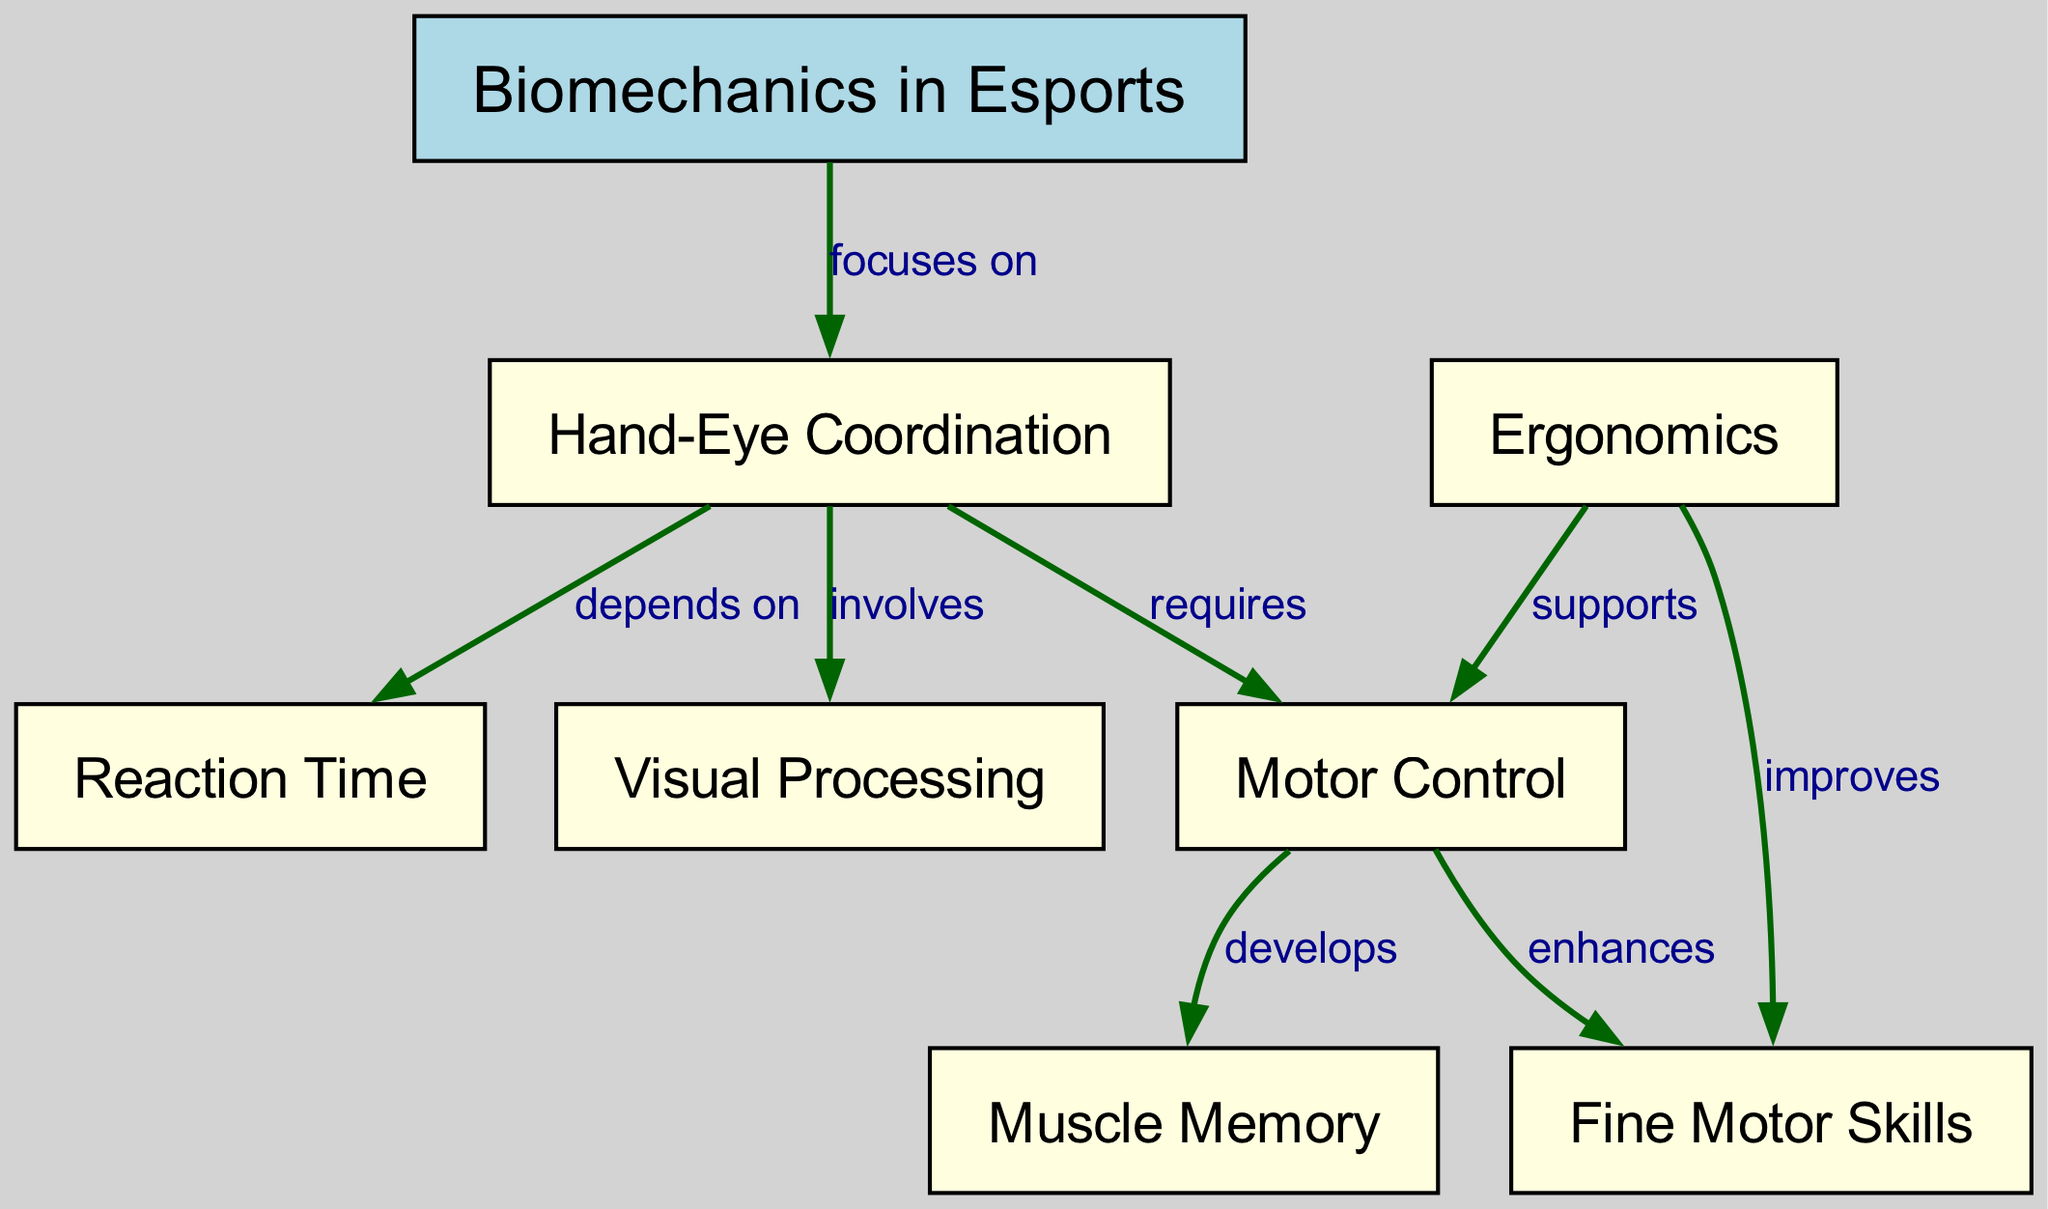What is the central theme of the diagram? The central theme can be found at the root node labeled "Biomechanics in Esports." This node serves as the foundation of the concept map, indicating the overall focus of the diagram.
Answer: Biomechanics in Esports How many nodes are in the diagram? By counting all the distinct nodes present, we find that there are a total of eight nodes. This includes both the main theme and the various components related to hand-eye coordination.
Answer: 8 What does "Hand-Eye Coordination" depend on? Moving through the edges from "Hand-Eye Coordination," we can see that it depends on "Reaction Time," which is clearly indicated by the edge connecting these two nodes.
Answer: Reaction Time Which node enhances fine motor skills? Following the connection from the "Motor Control" node, we look for which element improves fine motor skills. The diagram shows that "Motor Control" enhances "Fine Motor Skills" through a direct edge.
Answer: Motor Control What supports motor control in esports? Starting at the "Motor Control" node, we see a direct relationship showing that "Ergonomics" supports motor control. This indicates that the design and arrangement of equipment can positively affect motor control in esports.
Answer: Ergonomics How is muscle memory related to motor control? Analyzing the connections, it shows that "Motor Control" develops "Muscle Memory." This suggests that improving control over one's movements aids in the development of muscle memory.
Answer: develops What role does ergonomics play in fine motor skills? From "Ergonomics," a direct edge indicates that it improves "Fine Motor Skills." This relationship signifies that proper ergonomic practices enhance the precision and efficiency of fine motor skills.
Answer: improves How many edges are there in total? By counting the connections between the nodes, we find that there are a total of seven edges in the diagram, which depict the relationships between different concepts.
Answer: 7 Which two nodes are connected by a relationship showing that one involves the other? The relationship where one element involves another can be seen between "Hand-Eye Coordination" and "Visual Processing." The edge indicates that visual processing is a part of hand-eye coordination.
Answer: Visual Processing What relationship does "Visual Processing" have with "Hand-Eye Coordination"? The edge from "Hand-Eye Coordination" to "Visual Processing" indicates that "Hand-Eye Coordination" involves "Visual Processing," highlighting how visual input is integral to coordinating movements.
Answer: involves 